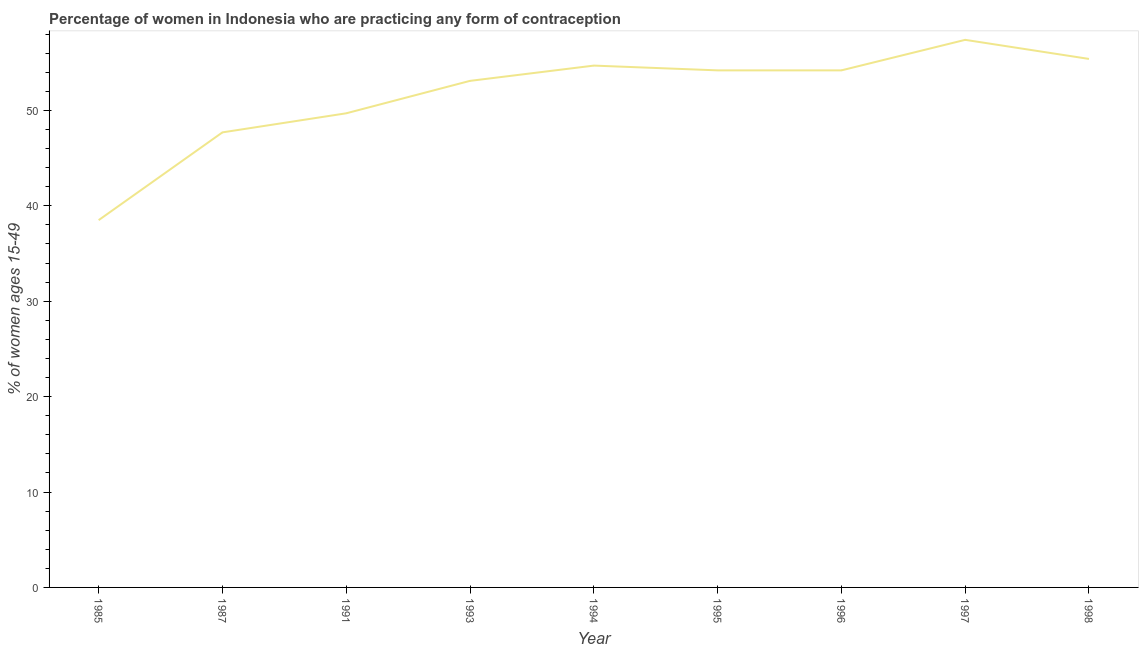What is the contraceptive prevalence in 1985?
Your response must be concise. 38.5. Across all years, what is the maximum contraceptive prevalence?
Make the answer very short. 57.4. Across all years, what is the minimum contraceptive prevalence?
Offer a very short reply. 38.5. In which year was the contraceptive prevalence minimum?
Your answer should be compact. 1985. What is the sum of the contraceptive prevalence?
Keep it short and to the point. 464.9. What is the difference between the contraceptive prevalence in 1985 and 1998?
Your response must be concise. -16.9. What is the average contraceptive prevalence per year?
Give a very brief answer. 51.66. What is the median contraceptive prevalence?
Offer a terse response. 54.2. In how many years, is the contraceptive prevalence greater than 42 %?
Provide a succinct answer. 8. What is the ratio of the contraceptive prevalence in 1985 to that in 1998?
Your response must be concise. 0.69. Is the difference between the contraceptive prevalence in 1994 and 1995 greater than the difference between any two years?
Offer a terse response. No. What is the difference between the highest and the second highest contraceptive prevalence?
Keep it short and to the point. 2. Is the sum of the contraceptive prevalence in 1987 and 1997 greater than the maximum contraceptive prevalence across all years?
Give a very brief answer. Yes. What is the difference between the highest and the lowest contraceptive prevalence?
Keep it short and to the point. 18.9. In how many years, is the contraceptive prevalence greater than the average contraceptive prevalence taken over all years?
Make the answer very short. 6. How many lines are there?
Ensure brevity in your answer.  1. What is the difference between two consecutive major ticks on the Y-axis?
Offer a very short reply. 10. Are the values on the major ticks of Y-axis written in scientific E-notation?
Your answer should be compact. No. Does the graph contain any zero values?
Give a very brief answer. No. What is the title of the graph?
Make the answer very short. Percentage of women in Indonesia who are practicing any form of contraception. What is the label or title of the X-axis?
Provide a succinct answer. Year. What is the label or title of the Y-axis?
Your response must be concise. % of women ages 15-49. What is the % of women ages 15-49 in 1985?
Your response must be concise. 38.5. What is the % of women ages 15-49 in 1987?
Your answer should be very brief. 47.7. What is the % of women ages 15-49 of 1991?
Provide a short and direct response. 49.7. What is the % of women ages 15-49 of 1993?
Your response must be concise. 53.1. What is the % of women ages 15-49 in 1994?
Your answer should be compact. 54.7. What is the % of women ages 15-49 of 1995?
Ensure brevity in your answer.  54.2. What is the % of women ages 15-49 of 1996?
Your answer should be compact. 54.2. What is the % of women ages 15-49 of 1997?
Offer a terse response. 57.4. What is the % of women ages 15-49 in 1998?
Offer a very short reply. 55.4. What is the difference between the % of women ages 15-49 in 1985 and 1987?
Provide a succinct answer. -9.2. What is the difference between the % of women ages 15-49 in 1985 and 1991?
Your answer should be very brief. -11.2. What is the difference between the % of women ages 15-49 in 1985 and 1993?
Your response must be concise. -14.6. What is the difference between the % of women ages 15-49 in 1985 and 1994?
Make the answer very short. -16.2. What is the difference between the % of women ages 15-49 in 1985 and 1995?
Keep it short and to the point. -15.7. What is the difference between the % of women ages 15-49 in 1985 and 1996?
Keep it short and to the point. -15.7. What is the difference between the % of women ages 15-49 in 1985 and 1997?
Keep it short and to the point. -18.9. What is the difference between the % of women ages 15-49 in 1985 and 1998?
Your answer should be very brief. -16.9. What is the difference between the % of women ages 15-49 in 1987 and 1991?
Make the answer very short. -2. What is the difference between the % of women ages 15-49 in 1987 and 1994?
Offer a terse response. -7. What is the difference between the % of women ages 15-49 in 1987 and 1995?
Your answer should be compact. -6.5. What is the difference between the % of women ages 15-49 in 1987 and 1996?
Ensure brevity in your answer.  -6.5. What is the difference between the % of women ages 15-49 in 1991 and 1993?
Provide a succinct answer. -3.4. What is the difference between the % of women ages 15-49 in 1991 and 1994?
Make the answer very short. -5. What is the difference between the % of women ages 15-49 in 1991 and 1997?
Your response must be concise. -7.7. What is the difference between the % of women ages 15-49 in 1991 and 1998?
Your answer should be very brief. -5.7. What is the difference between the % of women ages 15-49 in 1993 and 1994?
Provide a succinct answer. -1.6. What is the difference between the % of women ages 15-49 in 1994 and 1995?
Provide a succinct answer. 0.5. What is the difference between the % of women ages 15-49 in 1994 and 1996?
Provide a succinct answer. 0.5. What is the difference between the % of women ages 15-49 in 1994 and 1997?
Keep it short and to the point. -2.7. What is the difference between the % of women ages 15-49 in 1995 and 1996?
Make the answer very short. 0. What is the difference between the % of women ages 15-49 in 1995 and 1997?
Offer a very short reply. -3.2. What is the difference between the % of women ages 15-49 in 1996 and 1998?
Your response must be concise. -1.2. What is the difference between the % of women ages 15-49 in 1997 and 1998?
Keep it short and to the point. 2. What is the ratio of the % of women ages 15-49 in 1985 to that in 1987?
Your answer should be compact. 0.81. What is the ratio of the % of women ages 15-49 in 1985 to that in 1991?
Give a very brief answer. 0.78. What is the ratio of the % of women ages 15-49 in 1985 to that in 1993?
Your response must be concise. 0.72. What is the ratio of the % of women ages 15-49 in 1985 to that in 1994?
Make the answer very short. 0.7. What is the ratio of the % of women ages 15-49 in 1985 to that in 1995?
Your response must be concise. 0.71. What is the ratio of the % of women ages 15-49 in 1985 to that in 1996?
Make the answer very short. 0.71. What is the ratio of the % of women ages 15-49 in 1985 to that in 1997?
Offer a very short reply. 0.67. What is the ratio of the % of women ages 15-49 in 1985 to that in 1998?
Give a very brief answer. 0.69. What is the ratio of the % of women ages 15-49 in 1987 to that in 1991?
Provide a succinct answer. 0.96. What is the ratio of the % of women ages 15-49 in 1987 to that in 1993?
Keep it short and to the point. 0.9. What is the ratio of the % of women ages 15-49 in 1987 to that in 1994?
Offer a terse response. 0.87. What is the ratio of the % of women ages 15-49 in 1987 to that in 1995?
Ensure brevity in your answer.  0.88. What is the ratio of the % of women ages 15-49 in 1987 to that in 1997?
Your answer should be compact. 0.83. What is the ratio of the % of women ages 15-49 in 1987 to that in 1998?
Provide a succinct answer. 0.86. What is the ratio of the % of women ages 15-49 in 1991 to that in 1993?
Ensure brevity in your answer.  0.94. What is the ratio of the % of women ages 15-49 in 1991 to that in 1994?
Make the answer very short. 0.91. What is the ratio of the % of women ages 15-49 in 1991 to that in 1995?
Provide a short and direct response. 0.92. What is the ratio of the % of women ages 15-49 in 1991 to that in 1996?
Give a very brief answer. 0.92. What is the ratio of the % of women ages 15-49 in 1991 to that in 1997?
Offer a terse response. 0.87. What is the ratio of the % of women ages 15-49 in 1991 to that in 1998?
Ensure brevity in your answer.  0.9. What is the ratio of the % of women ages 15-49 in 1993 to that in 1994?
Provide a succinct answer. 0.97. What is the ratio of the % of women ages 15-49 in 1993 to that in 1996?
Offer a terse response. 0.98. What is the ratio of the % of women ages 15-49 in 1993 to that in 1997?
Provide a succinct answer. 0.93. What is the ratio of the % of women ages 15-49 in 1993 to that in 1998?
Provide a succinct answer. 0.96. What is the ratio of the % of women ages 15-49 in 1994 to that in 1995?
Provide a succinct answer. 1.01. What is the ratio of the % of women ages 15-49 in 1994 to that in 1997?
Your answer should be very brief. 0.95. What is the ratio of the % of women ages 15-49 in 1995 to that in 1997?
Your answer should be compact. 0.94. What is the ratio of the % of women ages 15-49 in 1996 to that in 1997?
Keep it short and to the point. 0.94. What is the ratio of the % of women ages 15-49 in 1996 to that in 1998?
Provide a short and direct response. 0.98. What is the ratio of the % of women ages 15-49 in 1997 to that in 1998?
Your answer should be compact. 1.04. 